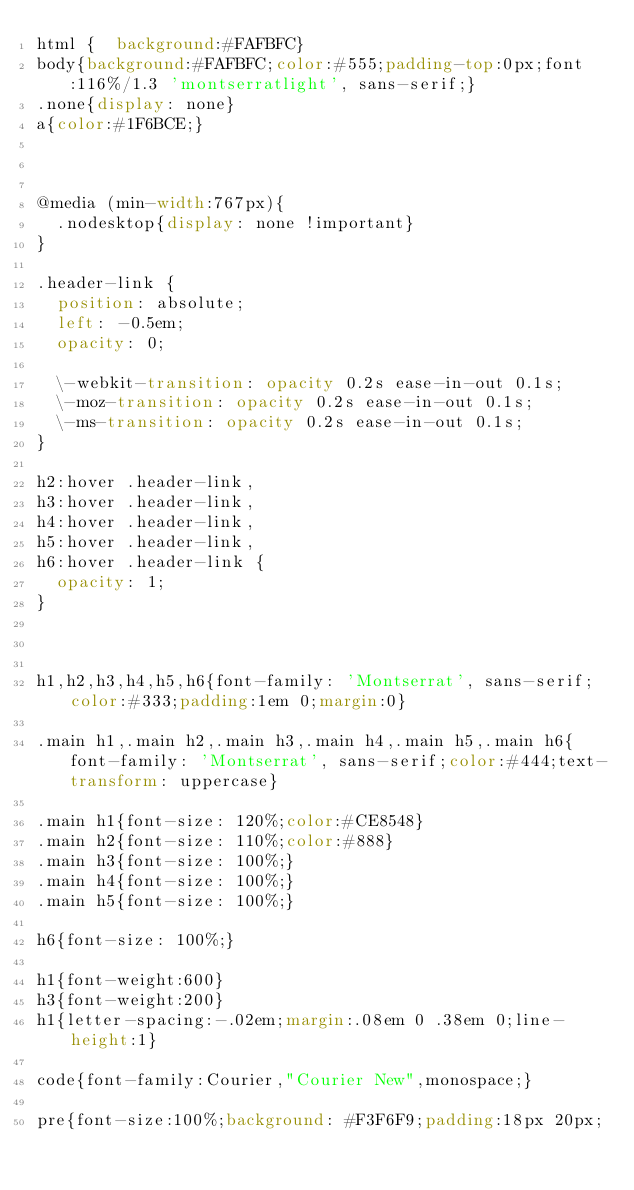Convert code to text. <code><loc_0><loc_0><loc_500><loc_500><_CSS_>html {  background:#FAFBFC}
body{background:#FAFBFC;color:#555;padding-top:0px;font:116%/1.3 'montserratlight', sans-serif;}
.none{display: none}
a{color:#1F6BCE;}



@media (min-width:767px){
  .nodesktop{display: none !important}
}

.header-link {
  position: absolute;
  left: -0.5em;
  opacity: 0;

  \-webkit-transition: opacity 0.2s ease-in-out 0.1s;
  \-moz-transition: opacity 0.2s ease-in-out 0.1s;
  \-ms-transition: opacity 0.2s ease-in-out 0.1s;
}

h2:hover .header-link,
h3:hover .header-link,
h4:hover .header-link,
h5:hover .header-link,
h6:hover .header-link {
  opacity: 1;
}



h1,h2,h3,h4,h5,h6{font-family: 'Montserrat', sans-serif;color:#333;padding:1em 0;margin:0}

.main h1,.main h2,.main h3,.main h4,.main h5,.main h6{font-family: 'Montserrat', sans-serif;color:#444;text-transform: uppercase}

.main h1{font-size: 120%;color:#CE8548}
.main h2{font-size: 110%;color:#888}
.main h3{font-size: 100%;}
.main h4{font-size: 100%;}
.main h5{font-size: 100%;}

h6{font-size: 100%;}

h1{font-weight:600}
h3{font-weight:200}
h1{letter-spacing:-.02em;margin:.08em 0 .38em 0;line-height:1}

code{font-family:Courier,"Courier New",monospace;}

pre{font-size:100%;background: #F3F6F9;padding:18px 20px;</code> 